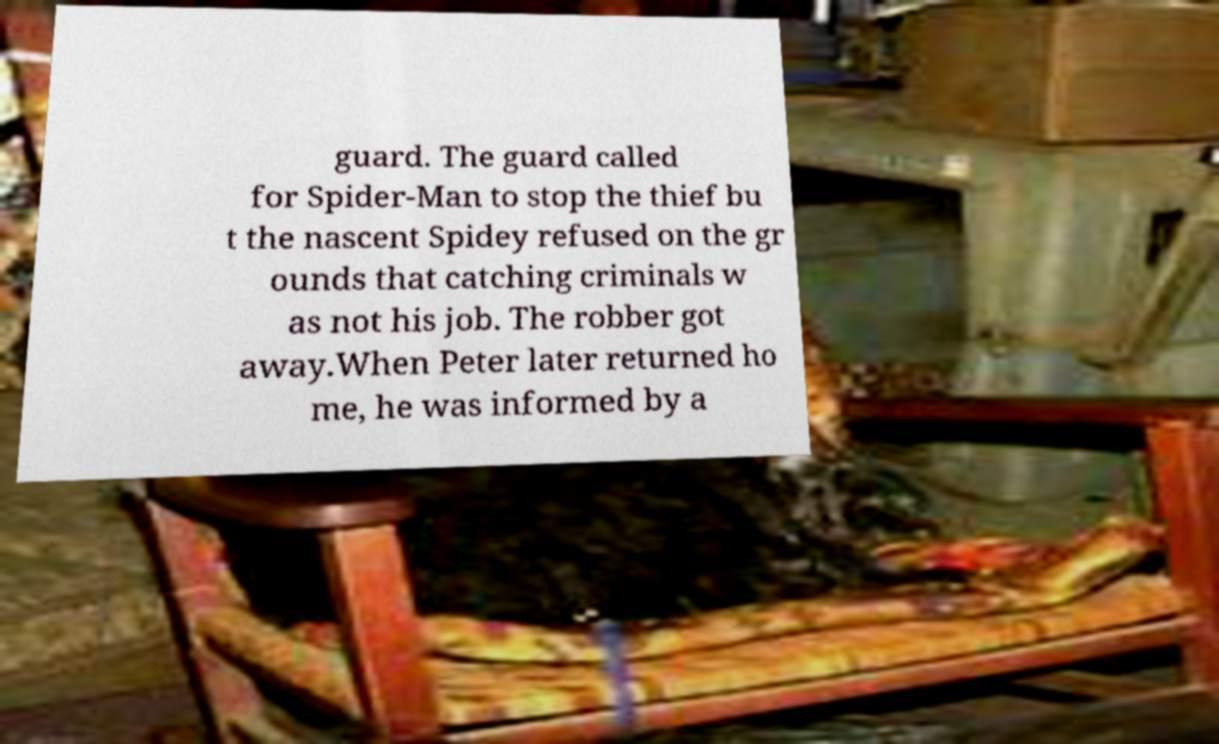Can you accurately transcribe the text from the provided image for me? guard. The guard called for Spider-Man to stop the thief bu t the nascent Spidey refused on the gr ounds that catching criminals w as not his job. The robber got away.When Peter later returned ho me, he was informed by a 